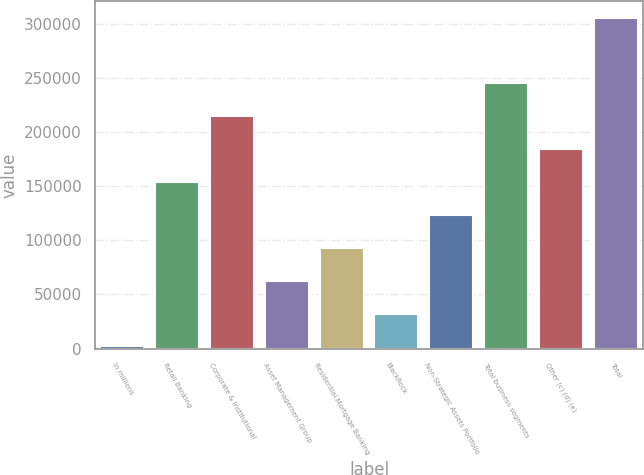Convert chart to OTSL. <chart><loc_0><loc_0><loc_500><loc_500><bar_chart><fcel>In millions<fcel>Retail Banking<fcel>Corporate & Institutional<fcel>Asset Management Group<fcel>Residential Mortgage Banking<fcel>BlackRock<fcel>Non-Strategic Assets Portfolio<fcel>Total business segments<fcel>Other (c) (d) (e)<fcel>Total<nl><fcel>2013<fcel>153838<fcel>214569<fcel>62743.2<fcel>93108.3<fcel>32378.1<fcel>123473<fcel>244934<fcel>184204<fcel>305664<nl></chart> 